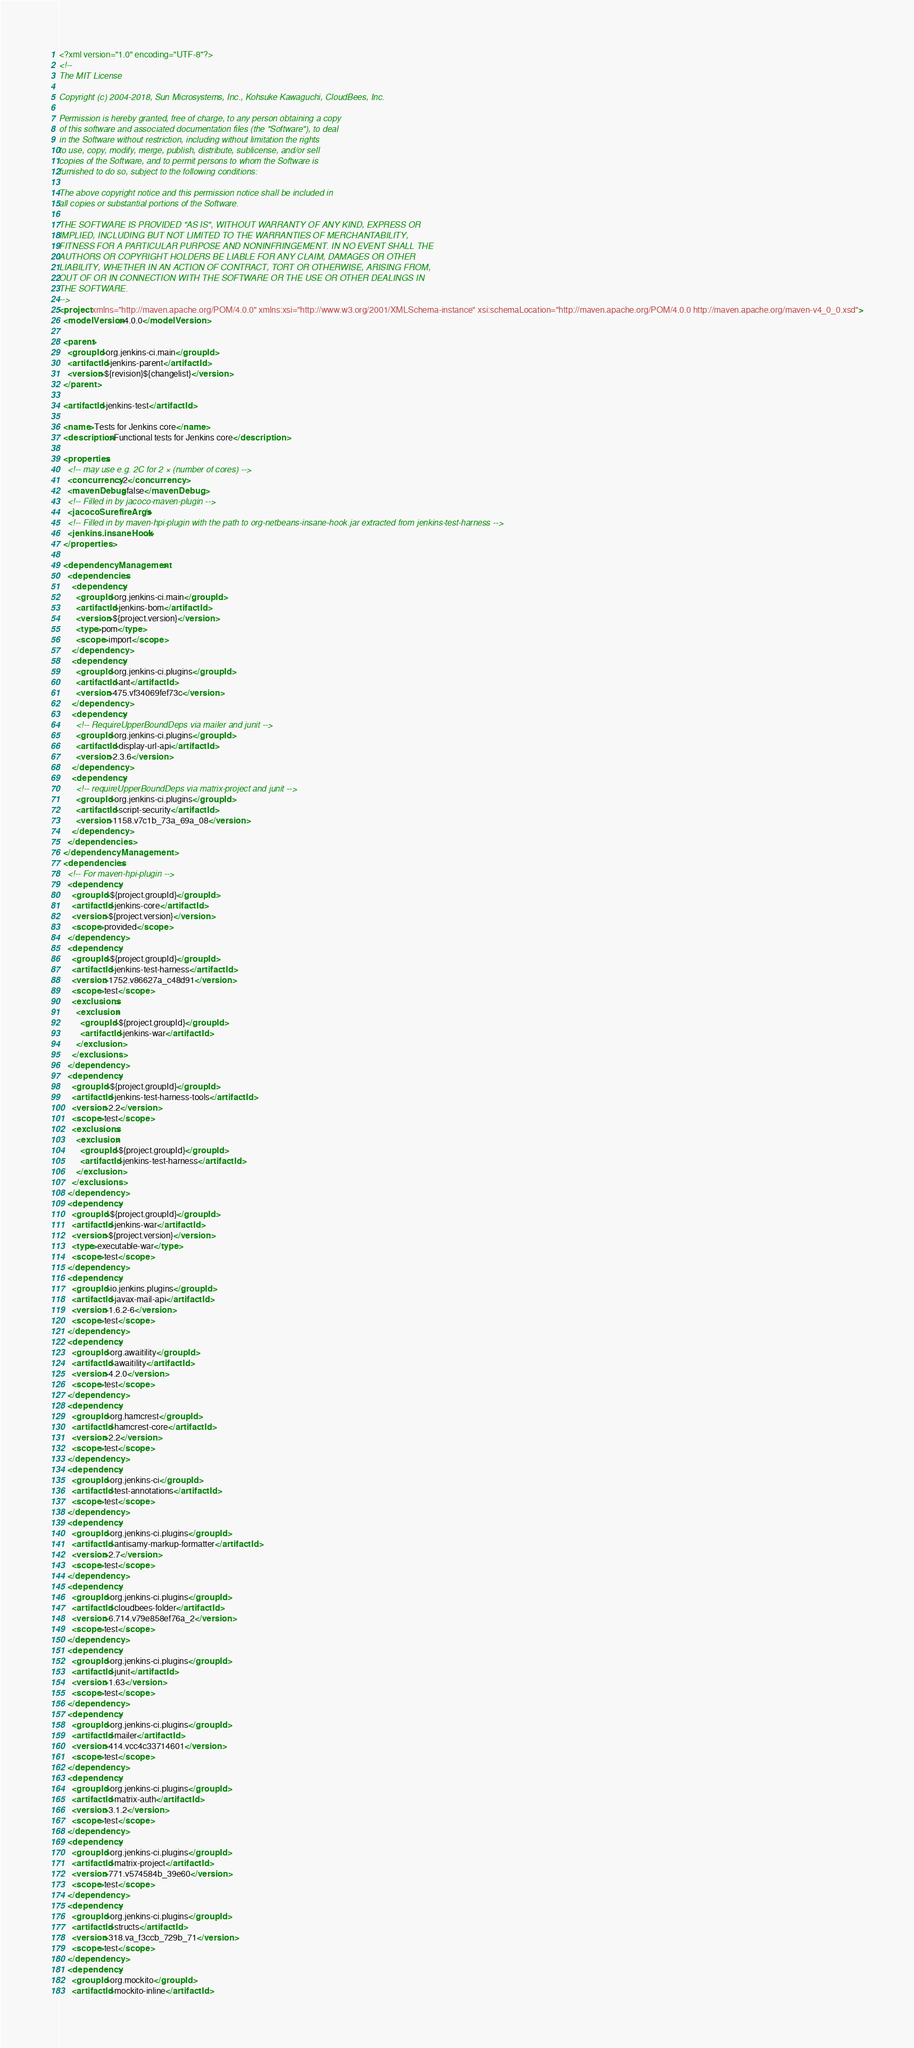Convert code to text. <code><loc_0><loc_0><loc_500><loc_500><_XML_><?xml version="1.0" encoding="UTF-8"?>
<!--
The MIT License

Copyright (c) 2004-2018, Sun Microsystems, Inc., Kohsuke Kawaguchi, CloudBees, Inc.

Permission is hereby granted, free of charge, to any person obtaining a copy
of this software and associated documentation files (the "Software"), to deal
in the Software without restriction, including without limitation the rights
to use, copy, modify, merge, publish, distribute, sublicense, and/or sell
copies of the Software, and to permit persons to whom the Software is
furnished to do so, subject to the following conditions:

The above copyright notice and this permission notice shall be included in
all copies or substantial portions of the Software.

THE SOFTWARE IS PROVIDED "AS IS", WITHOUT WARRANTY OF ANY KIND, EXPRESS OR
IMPLIED, INCLUDING BUT NOT LIMITED TO THE WARRANTIES OF MERCHANTABILITY,
FITNESS FOR A PARTICULAR PURPOSE AND NONINFRINGEMENT. IN NO EVENT SHALL THE
AUTHORS OR COPYRIGHT HOLDERS BE LIABLE FOR ANY CLAIM, DAMAGES OR OTHER
LIABILITY, WHETHER IN AN ACTION OF CONTRACT, TORT OR OTHERWISE, ARISING FROM,
OUT OF OR IN CONNECTION WITH THE SOFTWARE OR THE USE OR OTHER DEALINGS IN
THE SOFTWARE.
-->
<project xmlns="http://maven.apache.org/POM/4.0.0" xmlns:xsi="http://www.w3.org/2001/XMLSchema-instance" xsi:schemaLocation="http://maven.apache.org/POM/4.0.0 http://maven.apache.org/maven-v4_0_0.xsd">
  <modelVersion>4.0.0</modelVersion>

  <parent>
    <groupId>org.jenkins-ci.main</groupId>
    <artifactId>jenkins-parent</artifactId>
    <version>${revision}${changelist}</version>
  </parent>

  <artifactId>jenkins-test</artifactId>

  <name>Tests for Jenkins core</name>
  <description>Functional tests for Jenkins core</description>

  <properties>
    <!-- may use e.g. 2C for 2 × (number of cores) -->
    <concurrency>2</concurrency>
    <mavenDebug>false</mavenDebug>
    <!-- Filled in by jacoco-maven-plugin -->
    <jacocoSurefireArgs />
    <!-- Filled in by maven-hpi-plugin with the path to org-netbeans-insane-hook.jar extracted from jenkins-test-harness -->
    <jenkins.insaneHook />
  </properties>

  <dependencyManagement>
    <dependencies>
      <dependency>
        <groupId>org.jenkins-ci.main</groupId>
        <artifactId>jenkins-bom</artifactId>
        <version>${project.version}</version>
        <type>pom</type>
        <scope>import</scope>
      </dependency>
      <dependency>
        <groupId>org.jenkins-ci.plugins</groupId>
        <artifactId>ant</artifactId>
        <version>475.vf34069fef73c</version>
      </dependency>
      <dependency>
        <!-- RequireUpperBoundDeps via mailer and junit -->
        <groupId>org.jenkins-ci.plugins</groupId>
        <artifactId>display-url-api</artifactId>
        <version>2.3.6</version>
      </dependency>
      <dependency>
        <!-- requireUpperBoundDeps via matrix-project and junit -->
        <groupId>org.jenkins-ci.plugins</groupId>
        <artifactId>script-security</artifactId>
        <version>1158.v7c1b_73a_69a_08</version>
      </dependency>
    </dependencies>
  </dependencyManagement>
  <dependencies>
    <!-- For maven-hpi-plugin -->
    <dependency>
      <groupId>${project.groupId}</groupId>
      <artifactId>jenkins-core</artifactId>
      <version>${project.version}</version>
      <scope>provided</scope>
    </dependency>
    <dependency>
      <groupId>${project.groupId}</groupId>
      <artifactId>jenkins-test-harness</artifactId>
      <version>1752.v86627a_c48d91</version>
      <scope>test</scope>
      <exclusions>
        <exclusion>
          <groupId>${project.groupId}</groupId>
          <artifactId>jenkins-war</artifactId>
        </exclusion>
      </exclusions>
    </dependency>
    <dependency>
      <groupId>${project.groupId}</groupId>
      <artifactId>jenkins-test-harness-tools</artifactId>
      <version>2.2</version>
      <scope>test</scope>
      <exclusions>
        <exclusion>
          <groupId>${project.groupId}</groupId>
          <artifactId>jenkins-test-harness</artifactId>
        </exclusion>
      </exclusions>
    </dependency>
    <dependency>
      <groupId>${project.groupId}</groupId>
      <artifactId>jenkins-war</artifactId>
      <version>${project.version}</version>
      <type>executable-war</type>
      <scope>test</scope>
    </dependency>
    <dependency>
      <groupId>io.jenkins.plugins</groupId>
      <artifactId>javax-mail-api</artifactId>
      <version>1.6.2-6</version>
      <scope>test</scope>
    </dependency>
    <dependency>
      <groupId>org.awaitility</groupId>
      <artifactId>awaitility</artifactId>
      <version>4.2.0</version>
      <scope>test</scope>
    </dependency>
    <dependency>
      <groupId>org.hamcrest</groupId>
      <artifactId>hamcrest-core</artifactId>
      <version>2.2</version>
      <scope>test</scope>
    </dependency>
    <dependency>
      <groupId>org.jenkins-ci</groupId>
      <artifactId>test-annotations</artifactId>
      <scope>test</scope>
    </dependency>
    <dependency>
      <groupId>org.jenkins-ci.plugins</groupId>
      <artifactId>antisamy-markup-formatter</artifactId>
      <version>2.7</version>
      <scope>test</scope>
    </dependency>
    <dependency>
      <groupId>org.jenkins-ci.plugins</groupId>
      <artifactId>cloudbees-folder</artifactId>
      <version>6.714.v79e858ef76a_2</version>
      <scope>test</scope>
    </dependency>
    <dependency>
      <groupId>org.jenkins-ci.plugins</groupId>
      <artifactId>junit</artifactId>
      <version>1.63</version>
      <scope>test</scope>
    </dependency>
    <dependency>
      <groupId>org.jenkins-ci.plugins</groupId>
      <artifactId>mailer</artifactId>
      <version>414.vcc4c33714601</version>
      <scope>test</scope>
    </dependency>
    <dependency>
      <groupId>org.jenkins-ci.plugins</groupId>
      <artifactId>matrix-auth</artifactId>
      <version>3.1.2</version>
      <scope>test</scope>
    </dependency>
    <dependency>
      <groupId>org.jenkins-ci.plugins</groupId>
      <artifactId>matrix-project</artifactId>
      <version>771.v574584b_39e60</version>
      <scope>test</scope>
    </dependency>
    <dependency>
      <groupId>org.jenkins-ci.plugins</groupId>
      <artifactId>structs</artifactId>
      <version>318.va_f3ccb_729b_71</version>
      <scope>test</scope>
    </dependency>
    <dependency>
      <groupId>org.mockito</groupId>
      <artifactId>mockito-inline</artifactId></code> 